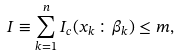Convert formula to latex. <formula><loc_0><loc_0><loc_500><loc_500>I \equiv \sum _ { k = 1 } ^ { n } I _ { c } ( x _ { k } \colon \beta _ { k } ) \leq m ,</formula> 